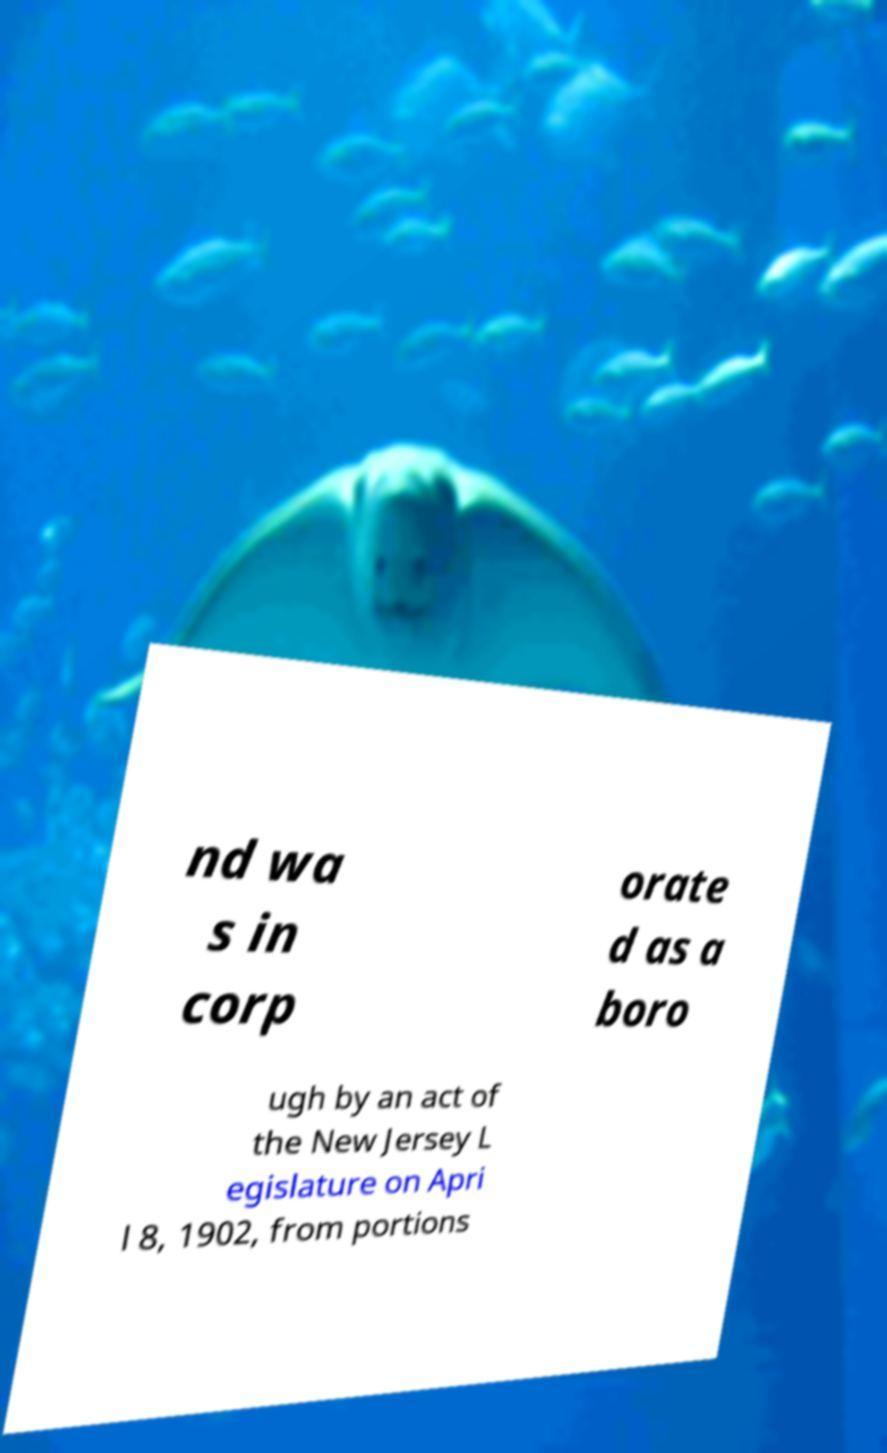Please identify and transcribe the text found in this image. nd wa s in corp orate d as a boro ugh by an act of the New Jersey L egislature on Apri l 8, 1902, from portions 